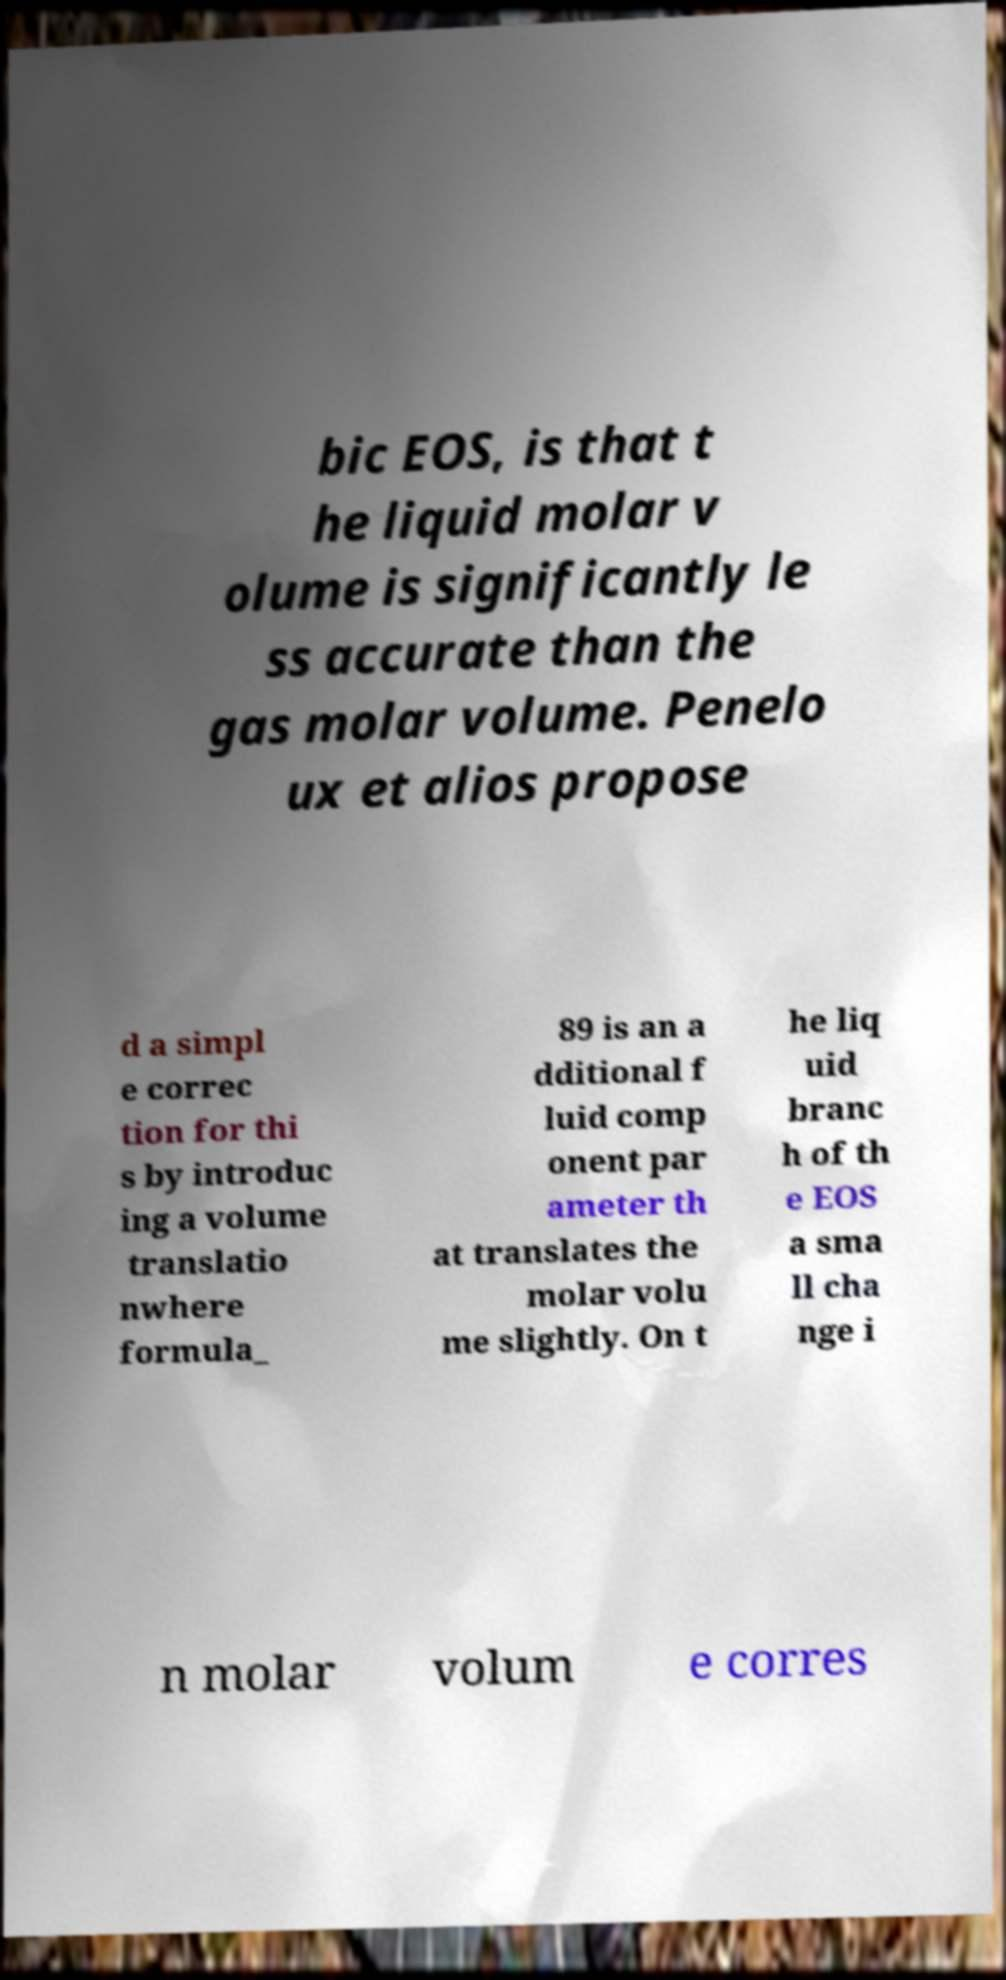For documentation purposes, I need the text within this image transcribed. Could you provide that? bic EOS, is that t he liquid molar v olume is significantly le ss accurate than the gas molar volume. Penelo ux et alios propose d a simpl e correc tion for thi s by introduc ing a volume translatio nwhere formula_ 89 is an a dditional f luid comp onent par ameter th at translates the molar volu me slightly. On t he liq uid branc h of th e EOS a sma ll cha nge i n molar volum e corres 